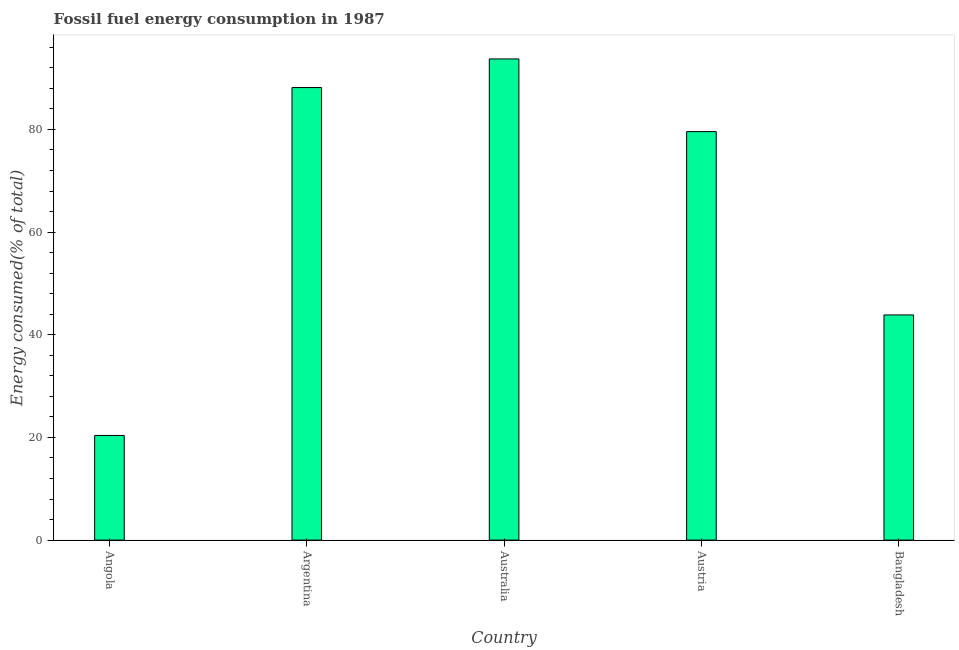Does the graph contain any zero values?
Keep it short and to the point. No. Does the graph contain grids?
Make the answer very short. No. What is the title of the graph?
Your answer should be compact. Fossil fuel energy consumption in 1987. What is the label or title of the Y-axis?
Your answer should be very brief. Energy consumed(% of total). What is the fossil fuel energy consumption in Austria?
Give a very brief answer. 79.58. Across all countries, what is the maximum fossil fuel energy consumption?
Your answer should be compact. 93.74. Across all countries, what is the minimum fossil fuel energy consumption?
Keep it short and to the point. 20.38. In which country was the fossil fuel energy consumption maximum?
Keep it short and to the point. Australia. In which country was the fossil fuel energy consumption minimum?
Provide a short and direct response. Angola. What is the sum of the fossil fuel energy consumption?
Keep it short and to the point. 325.73. What is the difference between the fossil fuel energy consumption in Argentina and Austria?
Your answer should be compact. 8.58. What is the average fossil fuel energy consumption per country?
Offer a terse response. 65.15. What is the median fossil fuel energy consumption?
Offer a terse response. 79.58. In how many countries, is the fossil fuel energy consumption greater than 60 %?
Make the answer very short. 3. What is the ratio of the fossil fuel energy consumption in Angola to that in Austria?
Your answer should be very brief. 0.26. Is the difference between the fossil fuel energy consumption in Angola and Bangladesh greater than the difference between any two countries?
Ensure brevity in your answer.  No. What is the difference between the highest and the second highest fossil fuel energy consumption?
Your response must be concise. 5.58. What is the difference between the highest and the lowest fossil fuel energy consumption?
Your response must be concise. 73.35. In how many countries, is the fossil fuel energy consumption greater than the average fossil fuel energy consumption taken over all countries?
Your response must be concise. 3. How many countries are there in the graph?
Provide a succinct answer. 5. Are the values on the major ticks of Y-axis written in scientific E-notation?
Make the answer very short. No. What is the Energy consumed(% of total) in Angola?
Offer a terse response. 20.38. What is the Energy consumed(% of total) in Argentina?
Offer a terse response. 88.16. What is the Energy consumed(% of total) of Australia?
Make the answer very short. 93.74. What is the Energy consumed(% of total) of Austria?
Provide a short and direct response. 79.58. What is the Energy consumed(% of total) of Bangladesh?
Your answer should be very brief. 43.86. What is the difference between the Energy consumed(% of total) in Angola and Argentina?
Offer a very short reply. -67.78. What is the difference between the Energy consumed(% of total) in Angola and Australia?
Keep it short and to the point. -73.35. What is the difference between the Energy consumed(% of total) in Angola and Austria?
Your response must be concise. -59.19. What is the difference between the Energy consumed(% of total) in Angola and Bangladesh?
Offer a terse response. -23.48. What is the difference between the Energy consumed(% of total) in Argentina and Australia?
Keep it short and to the point. -5.58. What is the difference between the Energy consumed(% of total) in Argentina and Austria?
Offer a very short reply. 8.58. What is the difference between the Energy consumed(% of total) in Argentina and Bangladesh?
Your answer should be compact. 44.3. What is the difference between the Energy consumed(% of total) in Australia and Austria?
Your answer should be compact. 14.16. What is the difference between the Energy consumed(% of total) in Australia and Bangladesh?
Give a very brief answer. 49.87. What is the difference between the Energy consumed(% of total) in Austria and Bangladesh?
Give a very brief answer. 35.71. What is the ratio of the Energy consumed(% of total) in Angola to that in Argentina?
Keep it short and to the point. 0.23. What is the ratio of the Energy consumed(% of total) in Angola to that in Australia?
Offer a terse response. 0.22. What is the ratio of the Energy consumed(% of total) in Angola to that in Austria?
Give a very brief answer. 0.26. What is the ratio of the Energy consumed(% of total) in Angola to that in Bangladesh?
Offer a terse response. 0.47. What is the ratio of the Energy consumed(% of total) in Argentina to that in Australia?
Offer a very short reply. 0.94. What is the ratio of the Energy consumed(% of total) in Argentina to that in Austria?
Your answer should be very brief. 1.11. What is the ratio of the Energy consumed(% of total) in Argentina to that in Bangladesh?
Provide a succinct answer. 2.01. What is the ratio of the Energy consumed(% of total) in Australia to that in Austria?
Ensure brevity in your answer.  1.18. What is the ratio of the Energy consumed(% of total) in Australia to that in Bangladesh?
Your response must be concise. 2.14. What is the ratio of the Energy consumed(% of total) in Austria to that in Bangladesh?
Offer a very short reply. 1.81. 